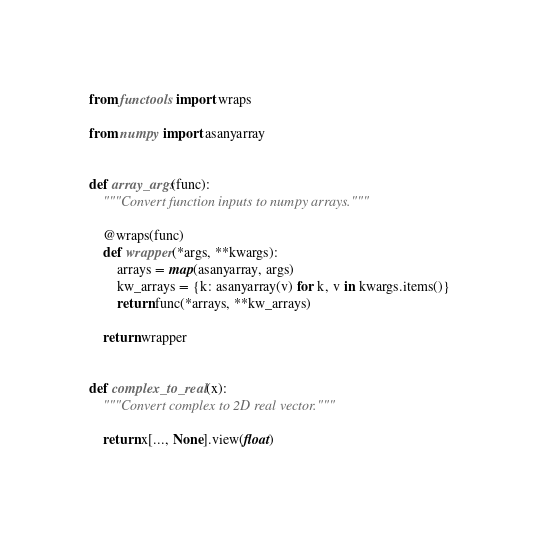<code> <loc_0><loc_0><loc_500><loc_500><_Python_>from functools import wraps

from numpy import asanyarray


def array_args(func):
    """Convert function inputs to numpy arrays."""

    @wraps(func)
    def wrapper(*args, **kwargs):
        arrays = map(asanyarray, args)
        kw_arrays = {k: asanyarray(v) for k, v in kwargs.items()}
        return func(*arrays, **kw_arrays)

    return wrapper


def complex_to_real(x):
    """Convert complex to 2D real vector."""

    return x[..., None].view(float)
</code> 